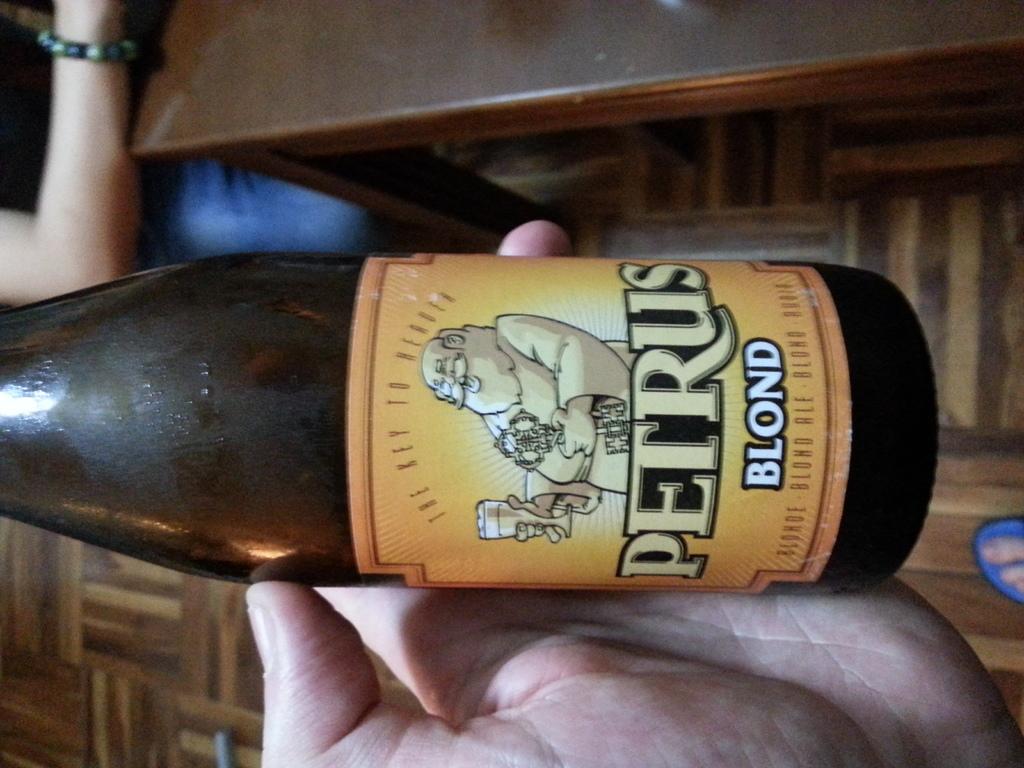What blend of beer is this?
Offer a very short reply. Blond. Name of the beer?
Your answer should be compact. Petrus blond. 